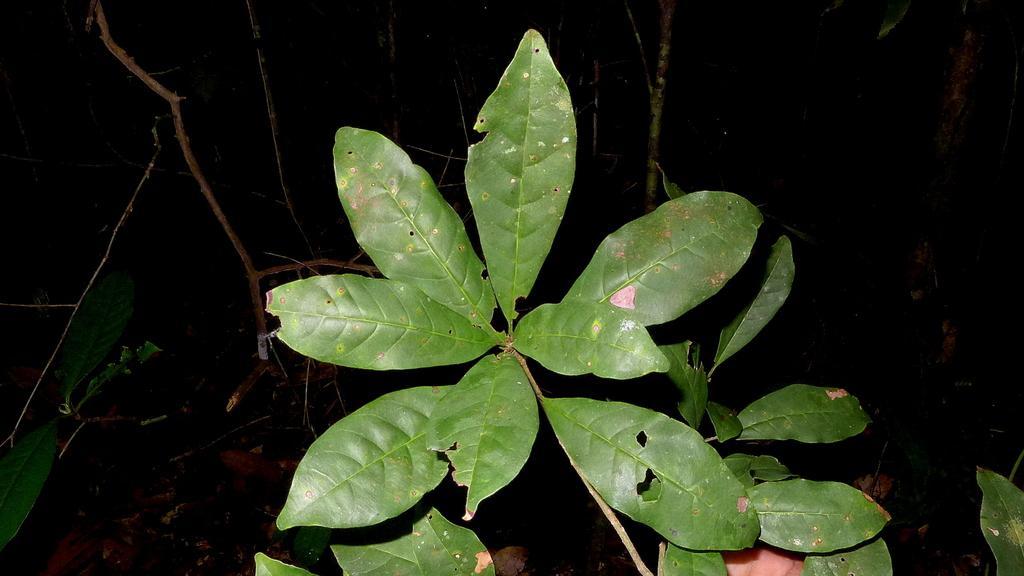Could you give a brief overview of what you see in this image? This image consist of a plant which is in the center and in the background there are dry branches. 